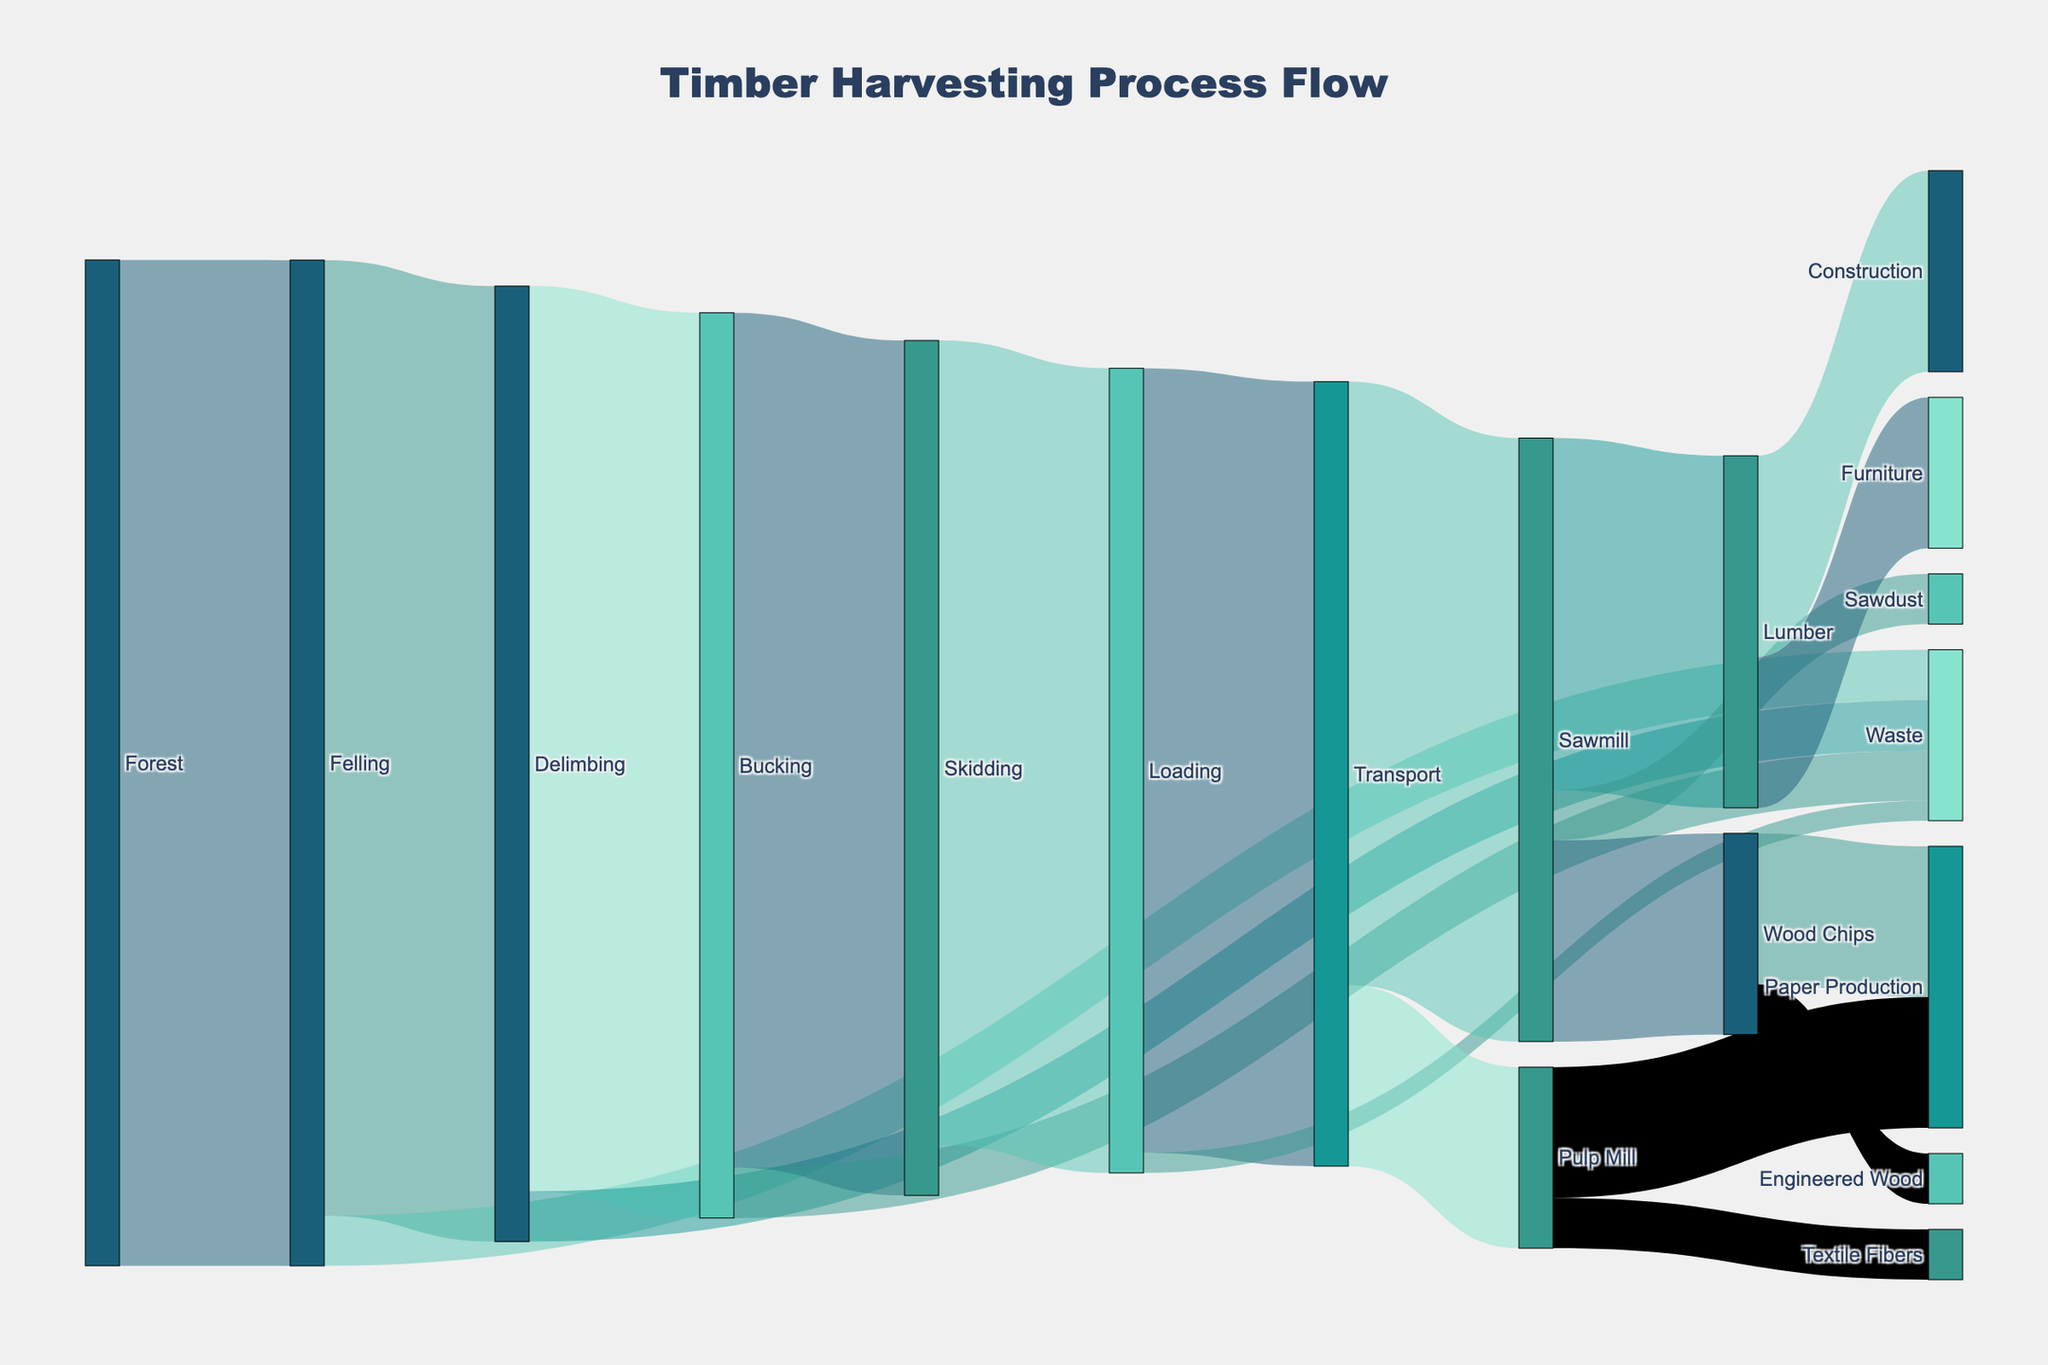What is the total amount of timber that is felled? According to the diagram, all timber harvested from the forest undergoes felling. The value for felling in the figure is 1000
Answer: 1000 What is the amount of timber transported to the sawmill? The diagram shows two outputs from the transport stage: 600 units to the sawmill and 180 units to the pulp mill. We focus on the sawmill value.
Answer: 600 How much waste is produced after delimbing and bucking combined? The delimbing process generates 50 units of waste, and the bucking process also generates 50 units of waste. Adding these together gives 50 + 50
Answer: 100 Which process has the highest amount of timber waste? The figure shows three processes generating waste: felling (50), delimbing (50), and bucking (50). Each amount is the same, so each process contributes equally with the highest waste of 50 units
Answer: Felling, Delimbing, Bucking (each 50) What is the amount of timber that goes into construction? The diagram indicates that after the sawmill, 350 units become lumber. Of this, 200 units are allocated to construction.
Answer: 200 How much timber is used for paper production and textile fibers combined? From the pulp mill, 130 units go to paper production, and 50 units go to textile fibers. Adding these values gives 130 + 50
Answer: 180 What proportion of timber transported goes to the sawmill compared to the pulp mill? The total transported is 780 units, with 600 going to the sawmill and 180 to the pulp mill. Calculating the proportion: 600/780 for sawmill and 180/780 for pulp mill, simplifies to approximately 0.77 and 0.23, respectively
Answer: 77% for sawmill, 23% for pulp mill What is the difference in the amount of timber used in construction versus furniture? The diagram shows 200 units of lumber go to construction and 150 units to furniture. The difference is 200 - 150
Answer: 50 What is the total amount of converted products after the sawmill? At the sawmill, 350 units become lumber, 200 units become wood chips, and 50 units become sawdust. Summing these values gives 350 + 200 + 50
Answer: 600 What amount of timber is processed for engineered wood? The figure shows that 50 units of wood chips are used for engineered wood production.
Answer: 50 